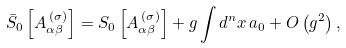<formula> <loc_0><loc_0><loc_500><loc_500>\bar { S } _ { 0 } \left [ A _ { \alpha \beta } ^ { \, ( \sigma ) } \right ] = S _ { 0 } \left [ A _ { \alpha \beta } ^ { \, ( \sigma ) } \right ] + g \int d ^ { n } x \, a _ { 0 } + O \left ( g ^ { 2 } \right ) ,</formula> 